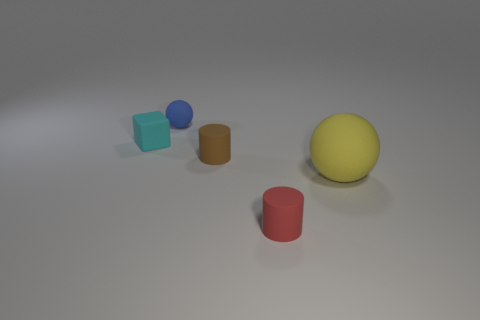Add 1 small brown objects. How many objects exist? 6 Subtract all cylinders. How many objects are left? 3 Add 4 brown cylinders. How many brown cylinders are left? 5 Add 5 green balls. How many green balls exist? 5 Subtract 0 gray balls. How many objects are left? 5 Subtract all brown matte things. Subtract all large blue matte things. How many objects are left? 4 